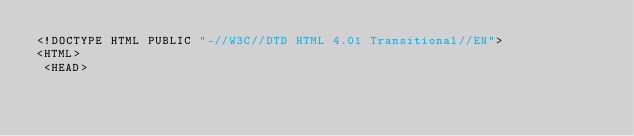Convert code to text. <code><loc_0><loc_0><loc_500><loc_500><_HTML_><!DOCTYPE HTML PUBLIC "-//W3C//DTD HTML 4.01 Transitional//EN">
<HTML>
 <HEAD></code> 